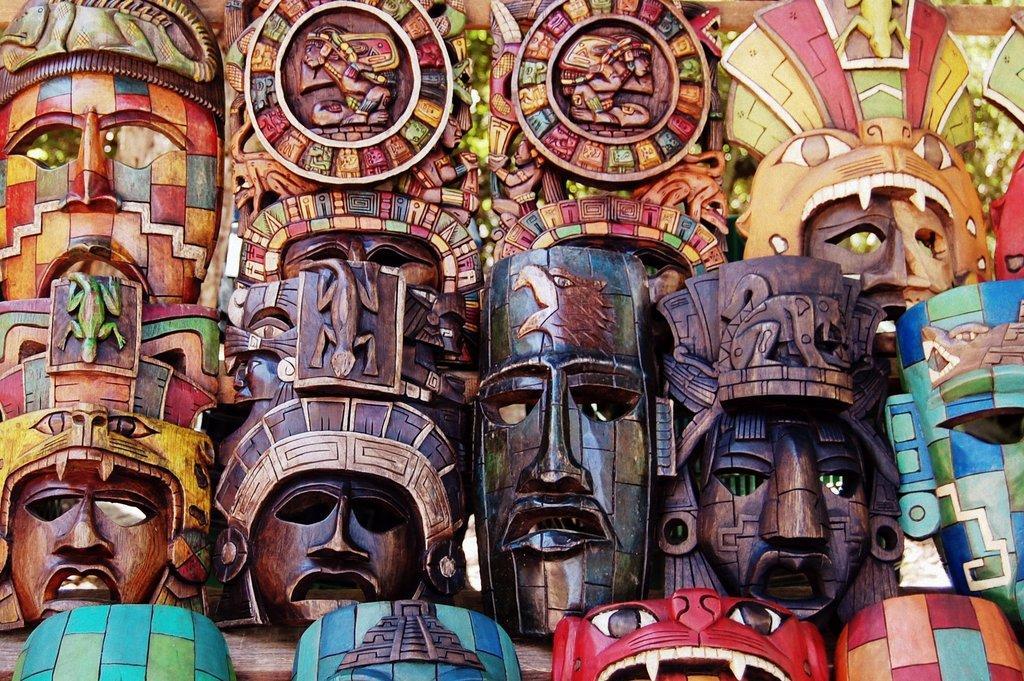Could you give a brief overview of what you see in this image? In this image there are wooden masks. In the background of the image it is blurry. 